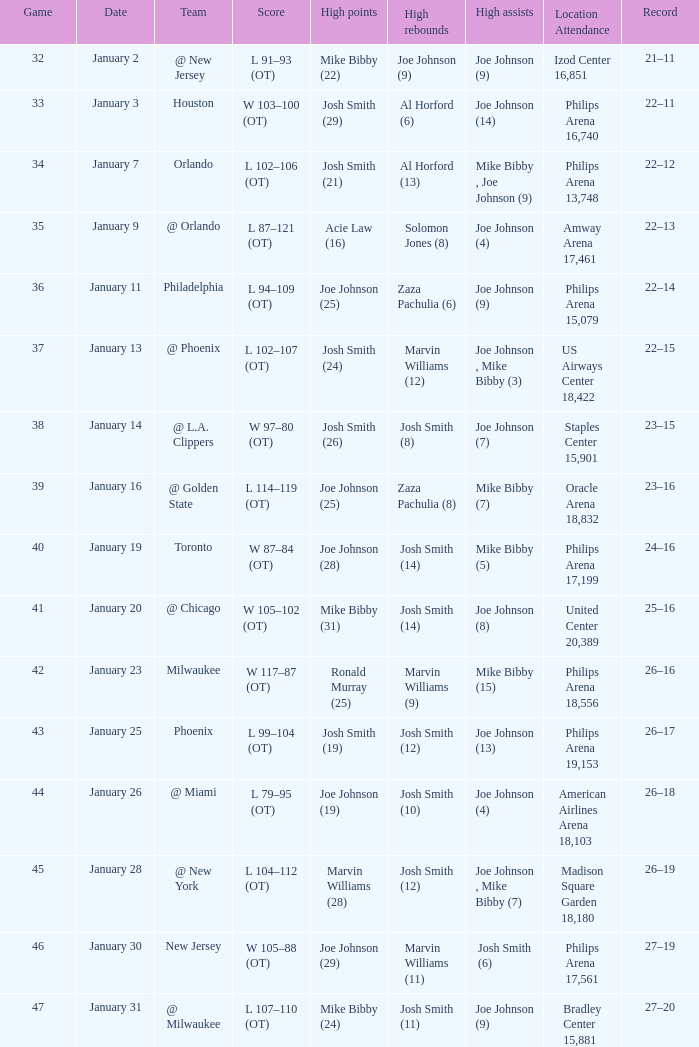When was game 35 scheduled? January 9. 